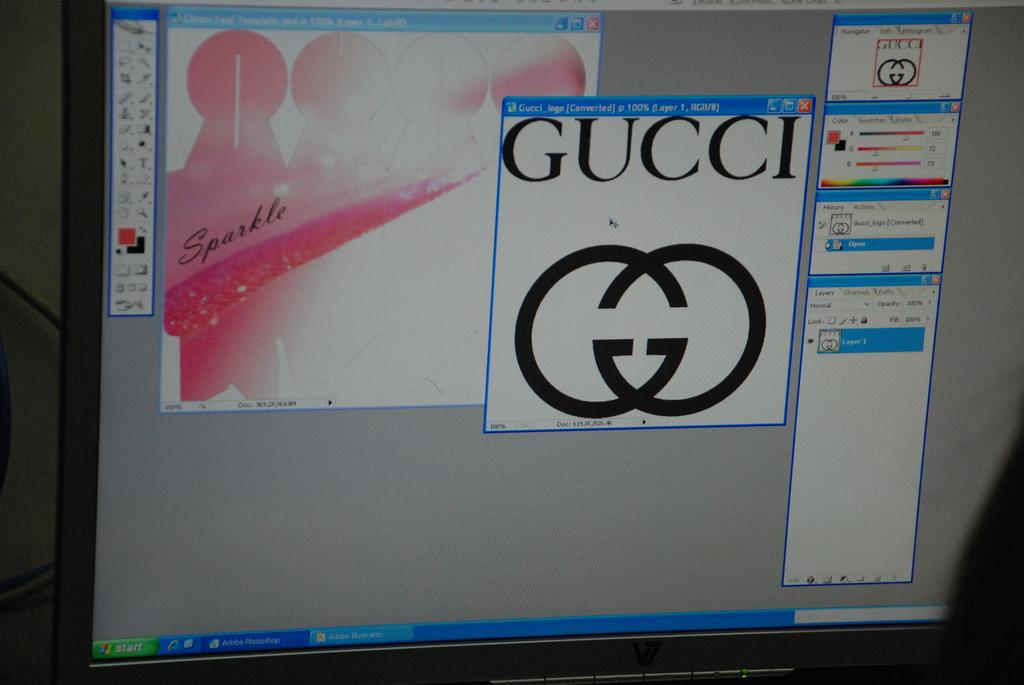<image>
Share a concise interpretation of the image provided. A computer screen shows the brand Gucci and its logo. 